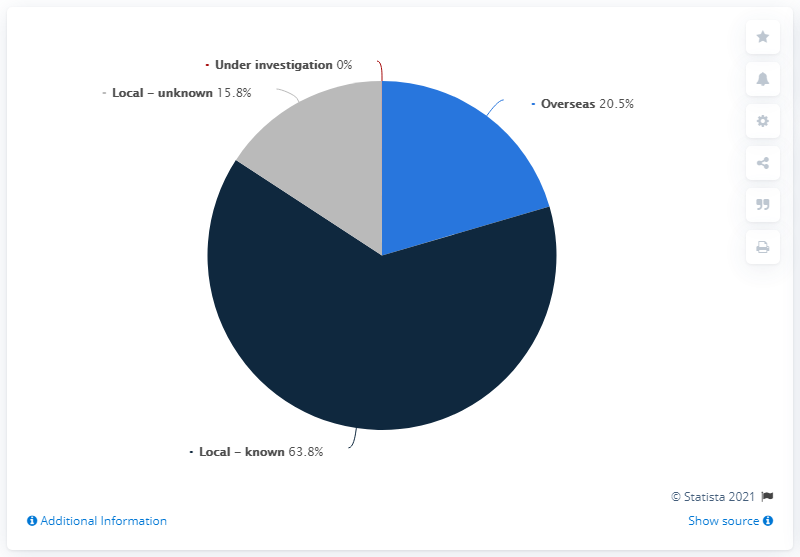Specify some key components in this picture. As of November 16, 2020, it was estimated that 63.8% of COVID-19 infections in Australia had a local known infection source. As of November 16, 2020, it was estimated that 79.6% of COVID-19 infections in Australia had a local infection source. 